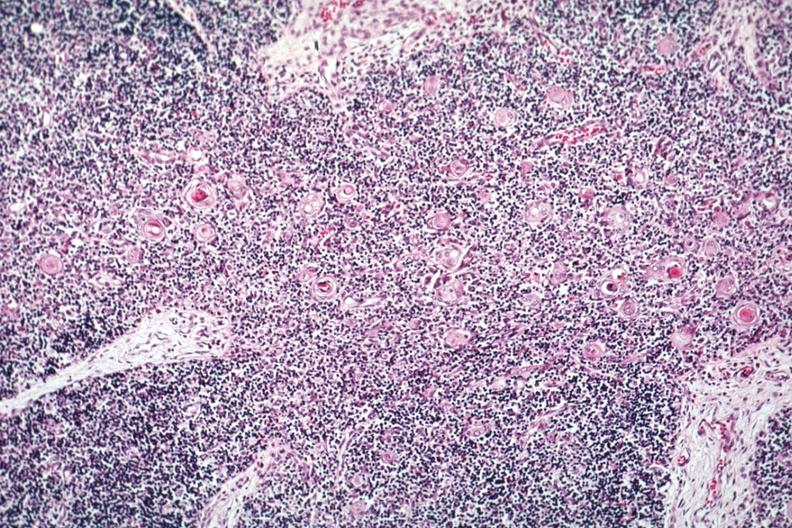s hematologic present?
Answer the question using a single word or phrase. Yes 